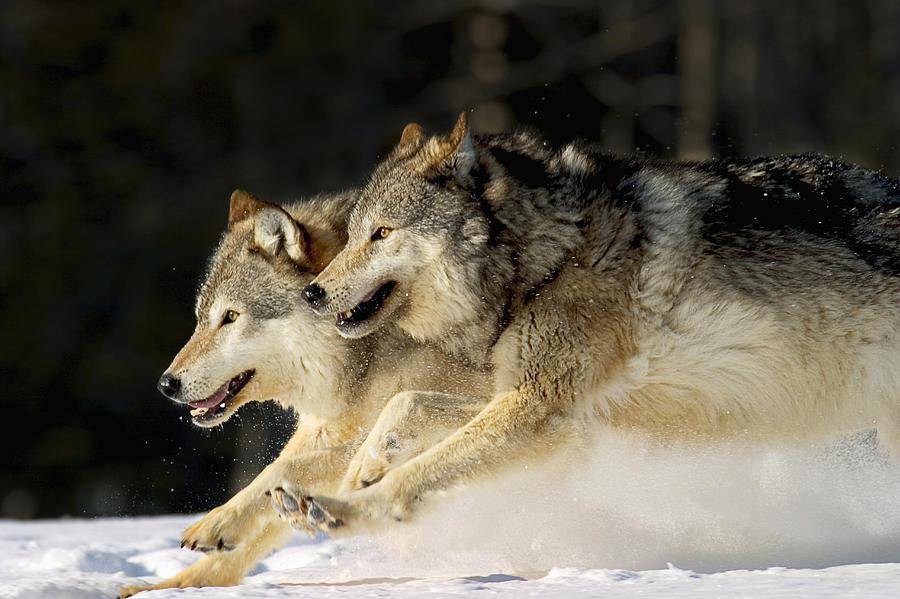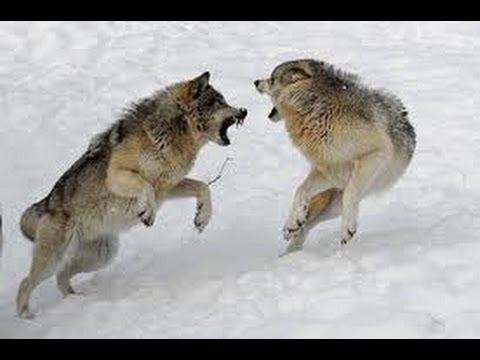The first image is the image on the left, the second image is the image on the right. Considering the images on both sides, is "The left image contains exactly two wolves." valid? Answer yes or no. Yes. The first image is the image on the left, the second image is the image on the right. For the images shown, is this caption "Each image contains exactly two wolves who are close together, and in at least one image, the two wolves are facing off, with snarling mouths." true? Answer yes or no. Yes. 